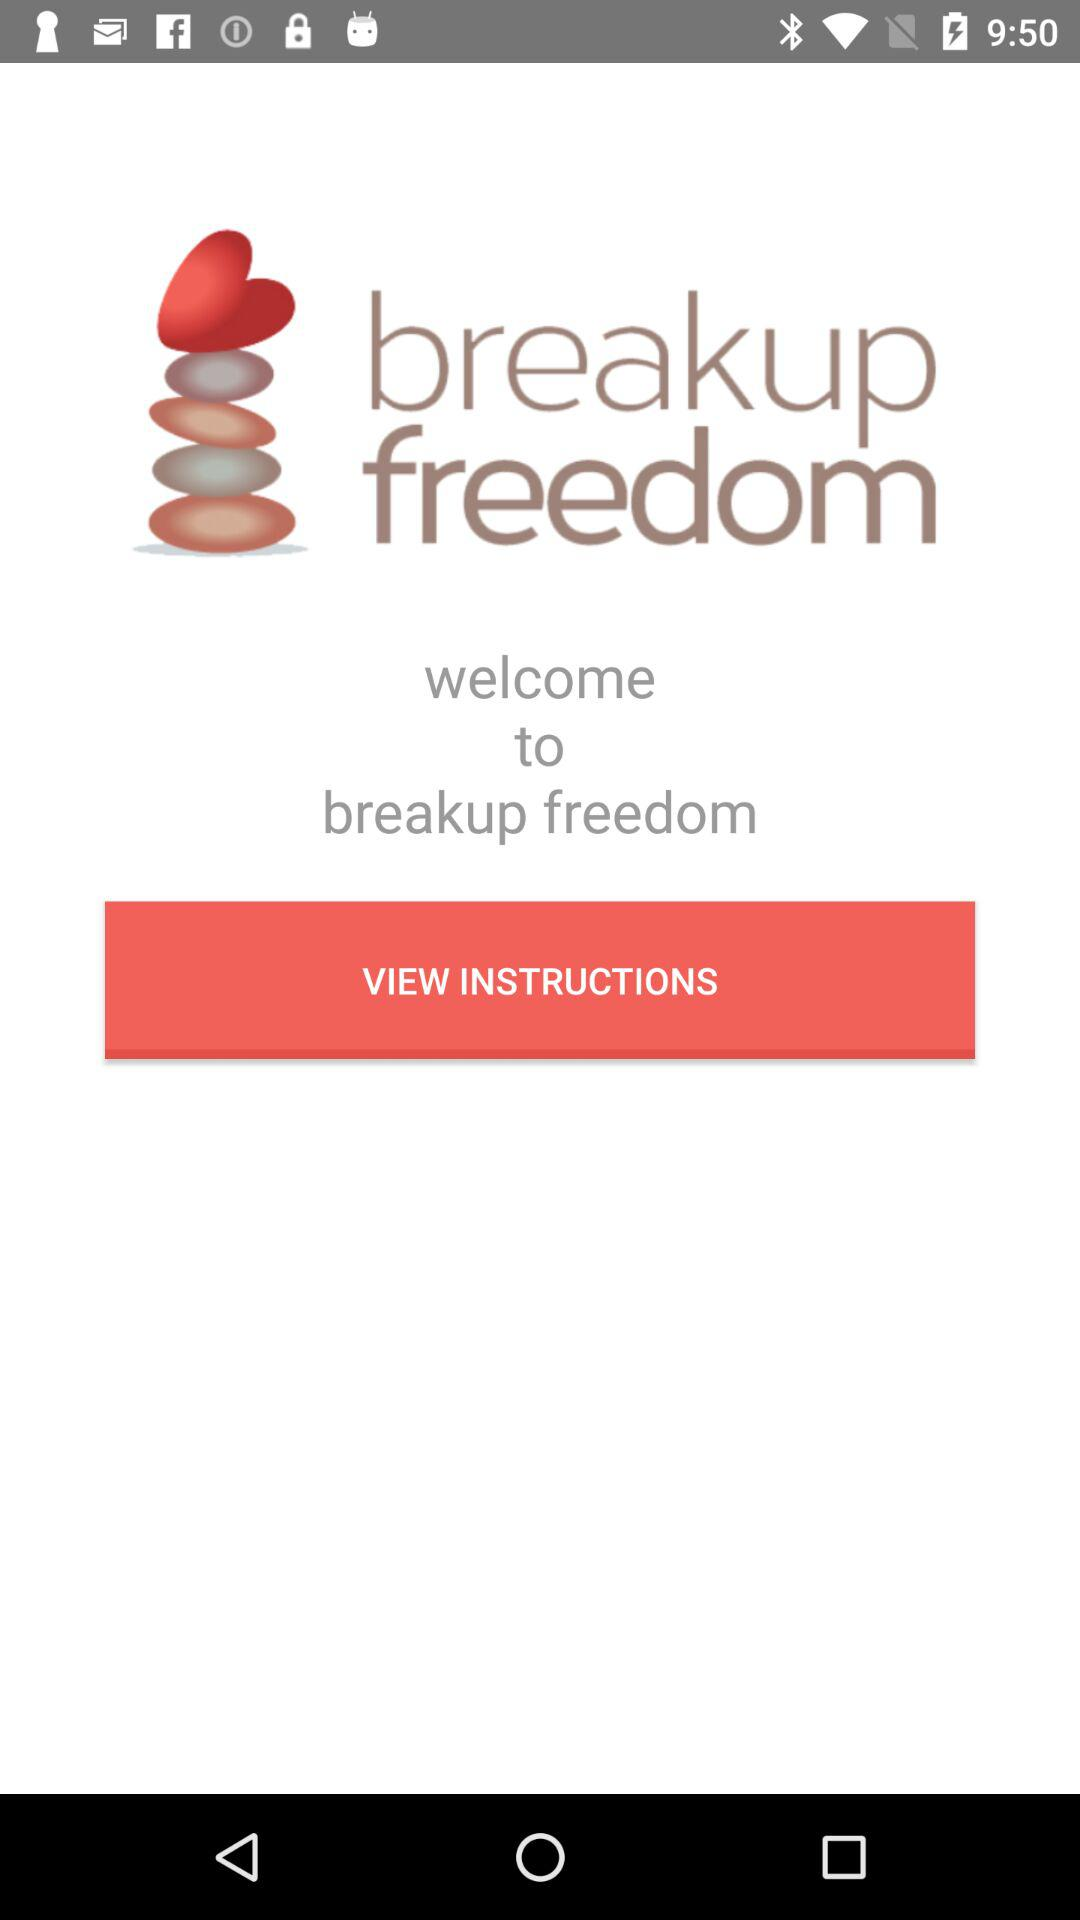What is the application name? The application name is "breakup freedom". 